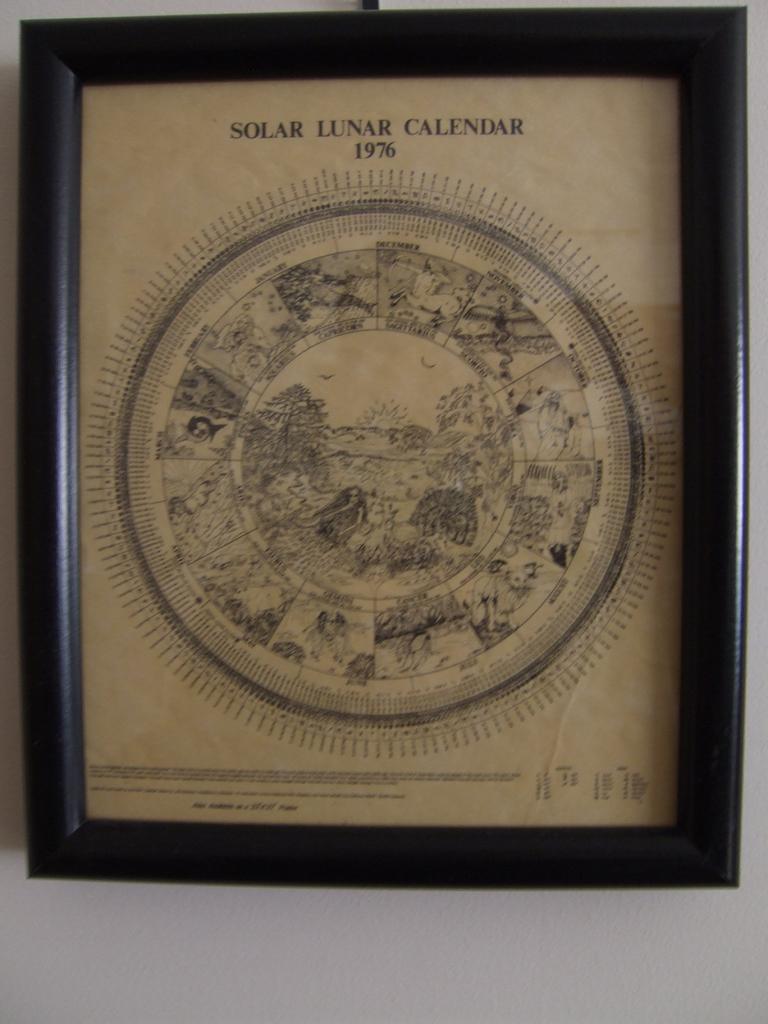What is this a picture of?
Offer a terse response. Solar lunar calendar. What year is on the print?
Offer a terse response. 1976. 